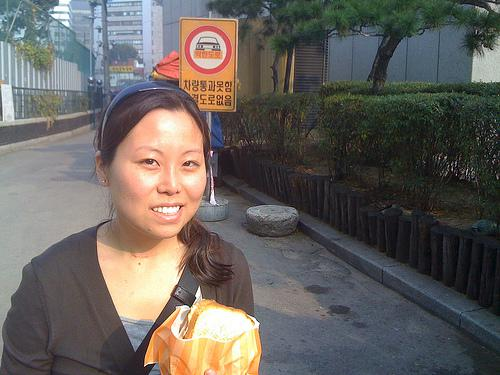Question: what is the color of the leaves?
Choices:
A. Green.
B. Brown.
C. Red.
D. Orange.
Answer with the letter. Answer: A Question: what is the color of the hair?
Choices:
A. Red.
B. Black.
C. Brown.
D. Grey.
Answer with the letter. Answer: B Question: what is the color of the road?
Choices:
A. Red.
B. Black.
C. Grey.
D. Yellow.
Answer with the letter. Answer: C 